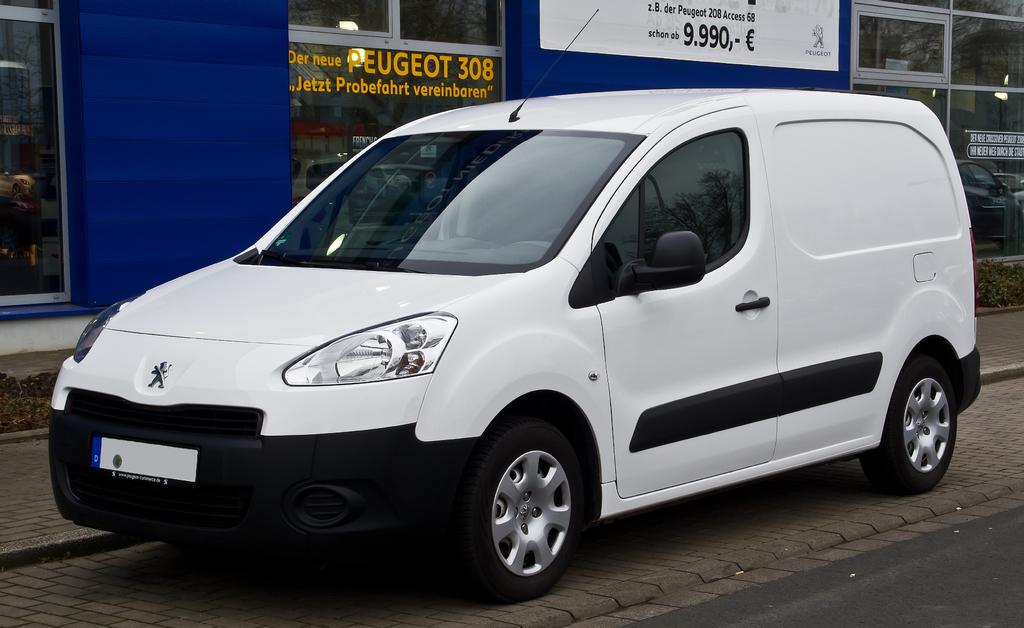What kind of car brand is shown here?
Keep it short and to the point. Peugeot. What number can be seen printed in yellow on the window?
Your answer should be compact. 308. 